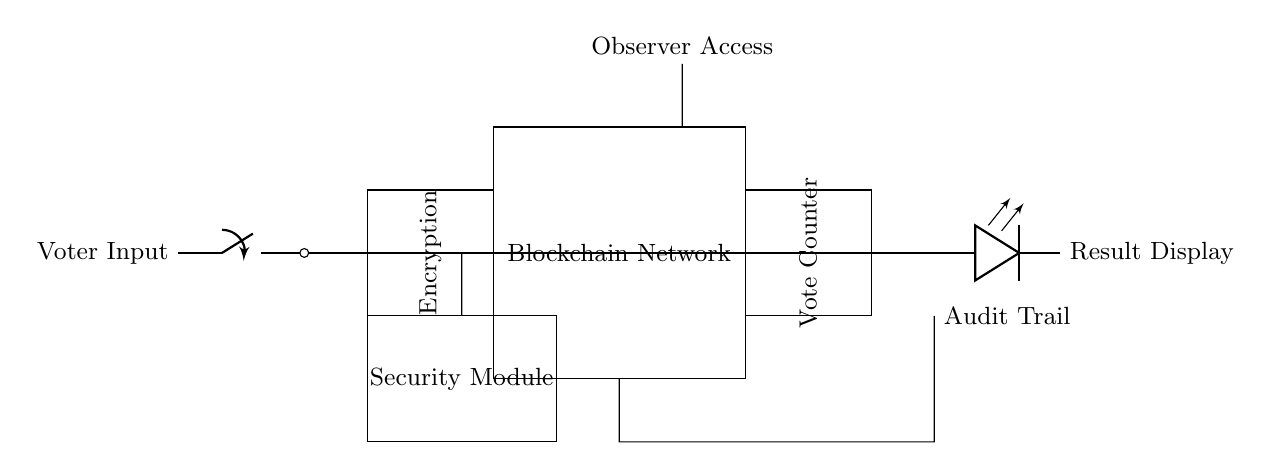What is the first component in the circuit? The first component is labeled as "Voter Input," and it is represented by a switch. It is located at the leftmost part of the circuit diagram.
Answer: Voter Input What module follows the security module? The module that follows the security module is the "Blockchain Network," represented by a rectangle. It directly receives input from the encryption module above.
Answer: Blockchain Network How many main modules are there in the circuit? There are three main modules: Encryption, Blockchain Network, and Vote Counter, each representing a distinct functional component in the voting system.
Answer: Three What is the purpose of the audit trail in the circuit? The audit trail serves as a supplementary check of the votes processed by the system, and it is shown as a connection below the Blockchain Network.
Answer: Verification What kind of access is provided to observers? Observer Access is depicted in the diagram as an additional short connection leading to the top of the Blockchain Network, indicating direct access by observers for transparency purposes.
Answer: Observer Access Which module is responsible for displaying the results? The module responsible for displaying the results is the "Result Display," indicated by an LED component on the far right side of the circuit diagram.
Answer: Result Display Explain the function of the encryption module. The encryption module secures the voter inputs before passing the data onto the Blockchain Network, ensuring that votes remain confidential and protected from tampering. This is essential for maintaining trust in the electoral process.
Answer: Secure votes 